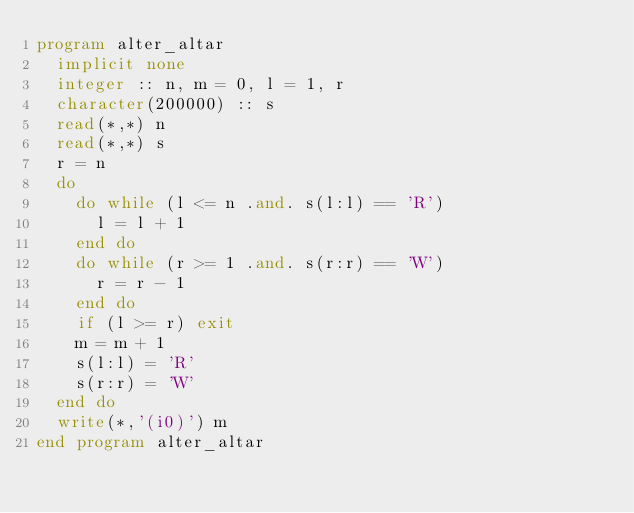<code> <loc_0><loc_0><loc_500><loc_500><_FORTRAN_>program alter_altar
  implicit none
  integer :: n, m = 0, l = 1, r
  character(200000) :: s
  read(*,*) n
  read(*,*) s
  r = n
  do
    do while (l <= n .and. s(l:l) == 'R')
      l = l + 1
    end do
    do while (r >= 1 .and. s(r:r) == 'W')
      r = r - 1
    end do
    if (l >= r) exit
    m = m + 1
    s(l:l) = 'R'
    s(r:r) = 'W'
  end do
  write(*,'(i0)') m
end program alter_altar</code> 